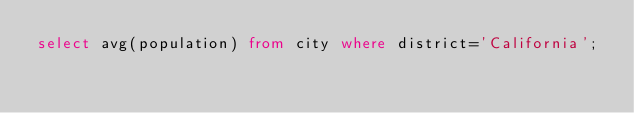Convert code to text. <code><loc_0><loc_0><loc_500><loc_500><_SQL_>select avg(population) from city where district='California';</code> 